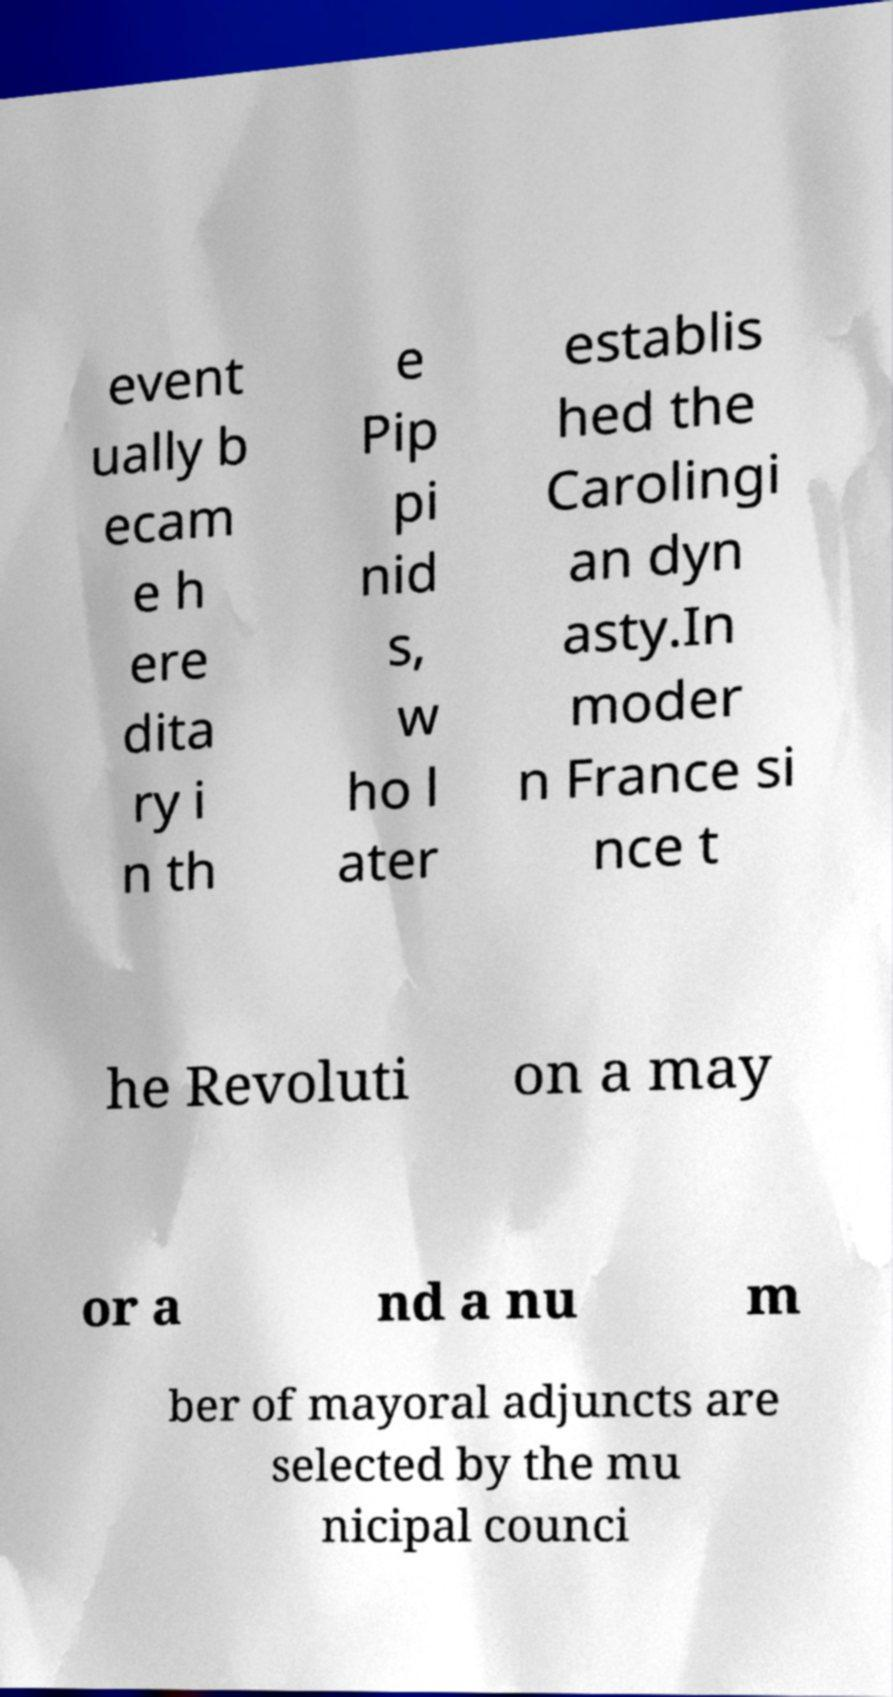Could you assist in decoding the text presented in this image and type it out clearly? event ually b ecam e h ere dita ry i n th e Pip pi nid s, w ho l ater establis hed the Carolingi an dyn asty.In moder n France si nce t he Revoluti on a may or a nd a nu m ber of mayoral adjuncts are selected by the mu nicipal counci 